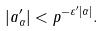<formula> <loc_0><loc_0><loc_500><loc_500>| a ^ { \prime } _ { \alpha } | < p ^ { - \varepsilon ^ { \prime } | \alpha | } .</formula> 